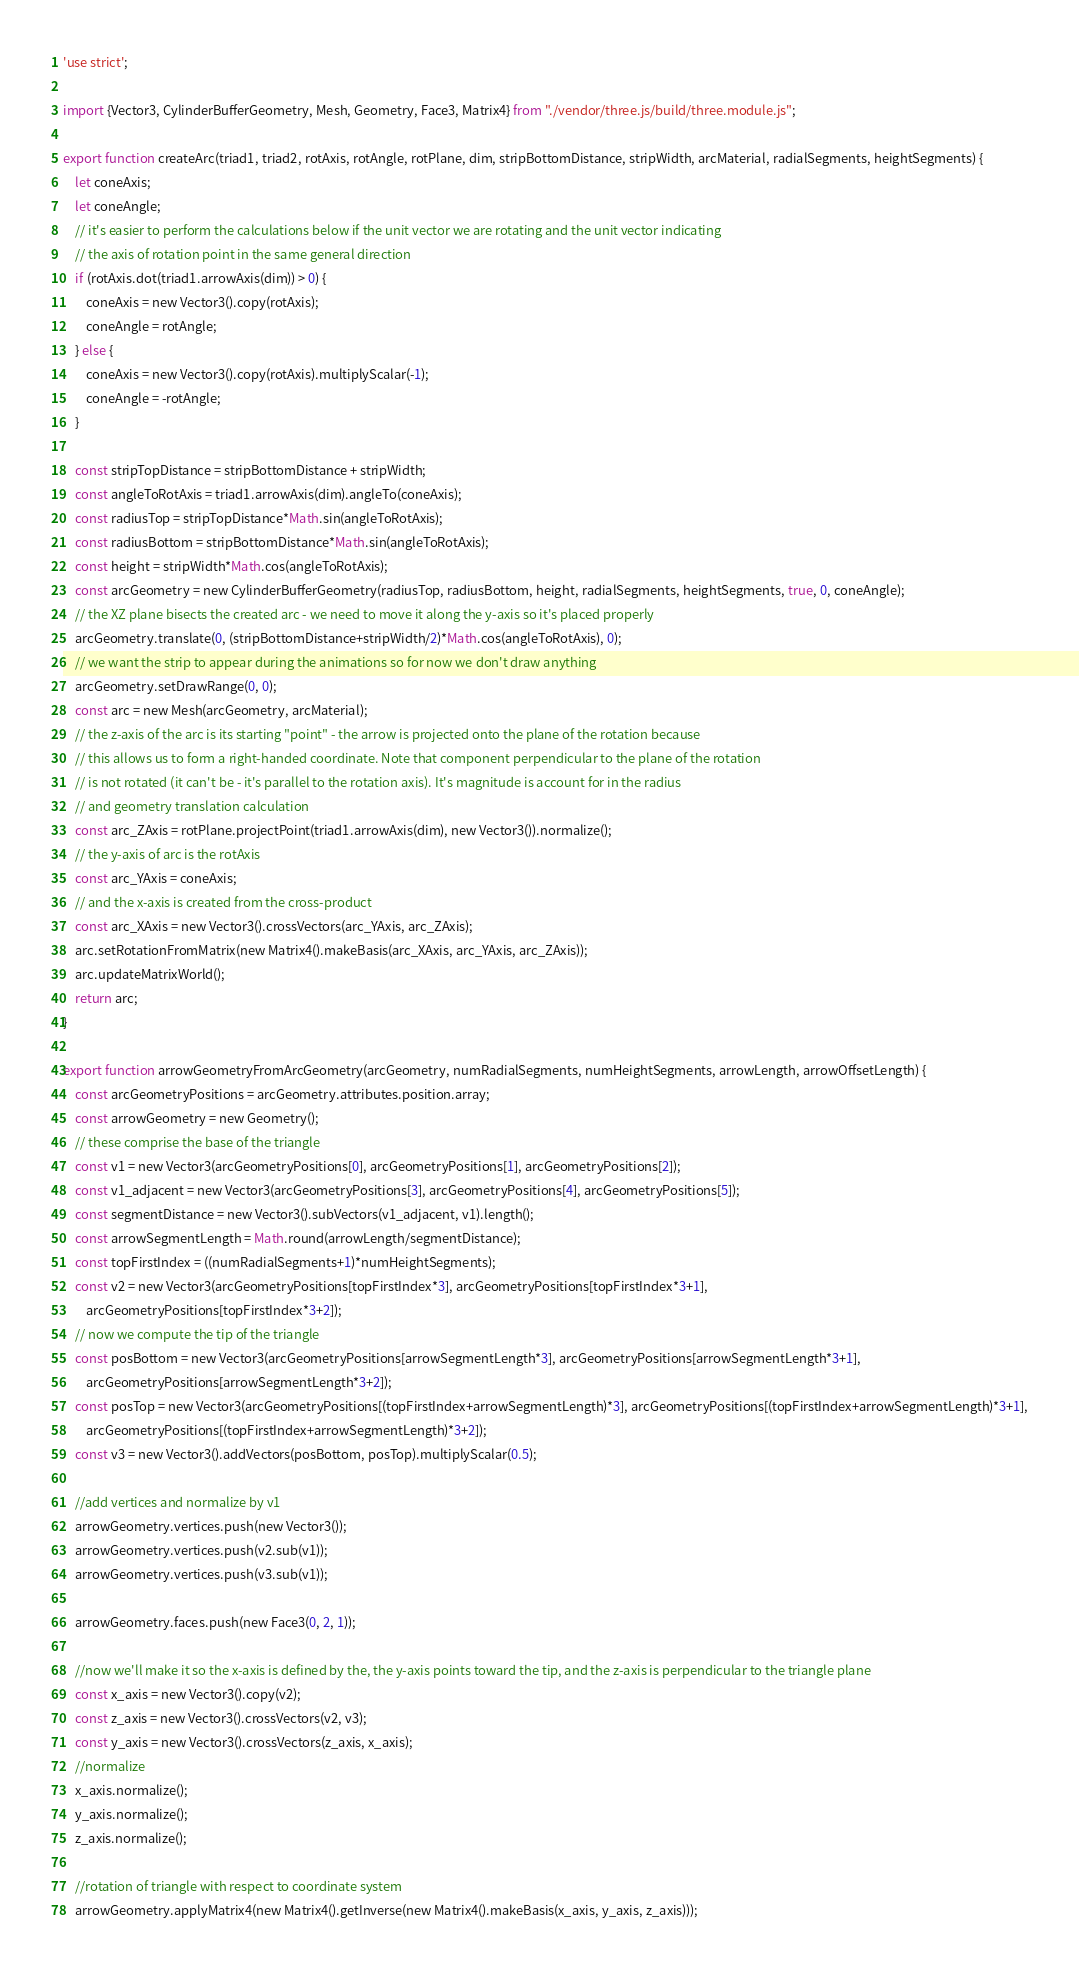Convert code to text. <code><loc_0><loc_0><loc_500><loc_500><_JavaScript_>'use strict';

import {Vector3, CylinderBufferGeometry, Mesh, Geometry, Face3, Matrix4} from "./vendor/three.js/build/three.module.js";

export function createArc(triad1, triad2, rotAxis, rotAngle, rotPlane, dim, stripBottomDistance, stripWidth, arcMaterial, radialSegments, heightSegments) {
    let coneAxis;
    let coneAngle;
    // it's easier to perform the calculations below if the unit vector we are rotating and the unit vector indicating
    // the axis of rotation point in the same general direction
    if (rotAxis.dot(triad1.arrowAxis(dim)) > 0) {
        coneAxis = new Vector3().copy(rotAxis);
        coneAngle = rotAngle;
    } else {
        coneAxis = new Vector3().copy(rotAxis).multiplyScalar(-1);
        coneAngle = -rotAngle;
    }

    const stripTopDistance = stripBottomDistance + stripWidth;
    const angleToRotAxis = triad1.arrowAxis(dim).angleTo(coneAxis);
    const radiusTop = stripTopDistance*Math.sin(angleToRotAxis);
    const radiusBottom = stripBottomDistance*Math.sin(angleToRotAxis);
    const height = stripWidth*Math.cos(angleToRotAxis);
    const arcGeometry = new CylinderBufferGeometry(radiusTop, radiusBottom, height, radialSegments, heightSegments, true, 0, coneAngle);
    // the XZ plane bisects the created arc - we need to move it along the y-axis so it's placed properly
    arcGeometry.translate(0, (stripBottomDistance+stripWidth/2)*Math.cos(angleToRotAxis), 0);
    // we want the strip to appear during the animations so for now we don't draw anything
    arcGeometry.setDrawRange(0, 0);
    const arc = new Mesh(arcGeometry, arcMaterial);
    // the z-axis of the arc is its starting "point" - the arrow is projected onto the plane of the rotation because
    // this allows us to form a right-handed coordinate. Note that component perpendicular to the plane of the rotation
    // is not rotated (it can't be - it's parallel to the rotation axis). It's magnitude is account for in the radius
    // and geometry translation calculation
    const arc_ZAxis = rotPlane.projectPoint(triad1.arrowAxis(dim), new Vector3()).normalize();
    // the y-axis of arc is the rotAxis
    const arc_YAxis = coneAxis;
    // and the x-axis is created from the cross-product
    const arc_XAxis = new Vector3().crossVectors(arc_YAxis, arc_ZAxis);
    arc.setRotationFromMatrix(new Matrix4().makeBasis(arc_XAxis, arc_YAxis, arc_ZAxis));
    arc.updateMatrixWorld();
    return arc;
}

export function arrowGeometryFromArcGeometry(arcGeometry, numRadialSegments, numHeightSegments, arrowLength, arrowOffsetLength) {
    const arcGeometryPositions = arcGeometry.attributes.position.array;
    const arrowGeometry = new Geometry();
    // these comprise the base of the triangle
    const v1 = new Vector3(arcGeometryPositions[0], arcGeometryPositions[1], arcGeometryPositions[2]);
    const v1_adjacent = new Vector3(arcGeometryPositions[3], arcGeometryPositions[4], arcGeometryPositions[5]);
    const segmentDistance = new Vector3().subVectors(v1_adjacent, v1).length();
    const arrowSegmentLength = Math.round(arrowLength/segmentDistance);
    const topFirstIndex = ((numRadialSegments+1)*numHeightSegments);
    const v2 = new Vector3(arcGeometryPositions[topFirstIndex*3], arcGeometryPositions[topFirstIndex*3+1],
        arcGeometryPositions[topFirstIndex*3+2]);
    // now we compute the tip of the triangle
    const posBottom = new Vector3(arcGeometryPositions[arrowSegmentLength*3], arcGeometryPositions[arrowSegmentLength*3+1],
        arcGeometryPositions[arrowSegmentLength*3+2]);
    const posTop = new Vector3(arcGeometryPositions[(topFirstIndex+arrowSegmentLength)*3], arcGeometryPositions[(topFirstIndex+arrowSegmentLength)*3+1],
        arcGeometryPositions[(topFirstIndex+arrowSegmentLength)*3+2]);
    const v3 = new Vector3().addVectors(posBottom, posTop).multiplyScalar(0.5);

    //add vertices and normalize by v1
    arrowGeometry.vertices.push(new Vector3());
    arrowGeometry.vertices.push(v2.sub(v1));
    arrowGeometry.vertices.push(v3.sub(v1));

    arrowGeometry.faces.push(new Face3(0, 2, 1));

    //now we'll make it so the x-axis is defined by the, the y-axis points toward the tip, and the z-axis is perpendicular to the triangle plane
    const x_axis = new Vector3().copy(v2);
    const z_axis = new Vector3().crossVectors(v2, v3);
    const y_axis = new Vector3().crossVectors(z_axis, x_axis);
    //normalize
    x_axis.normalize();
    y_axis.normalize();
    z_axis.normalize();

    //rotation of triangle with respect to coordinate system
    arrowGeometry.applyMatrix4(new Matrix4().getInverse(new Matrix4().makeBasis(x_axis, y_axis, z_axis)));</code> 